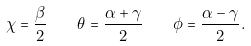Convert formula to latex. <formula><loc_0><loc_0><loc_500><loc_500>\chi = \frac { \beta } { 2 } \quad \theta = \frac { \alpha + \gamma } { 2 } \quad \phi = \frac { \alpha - \gamma } { 2 } .</formula> 